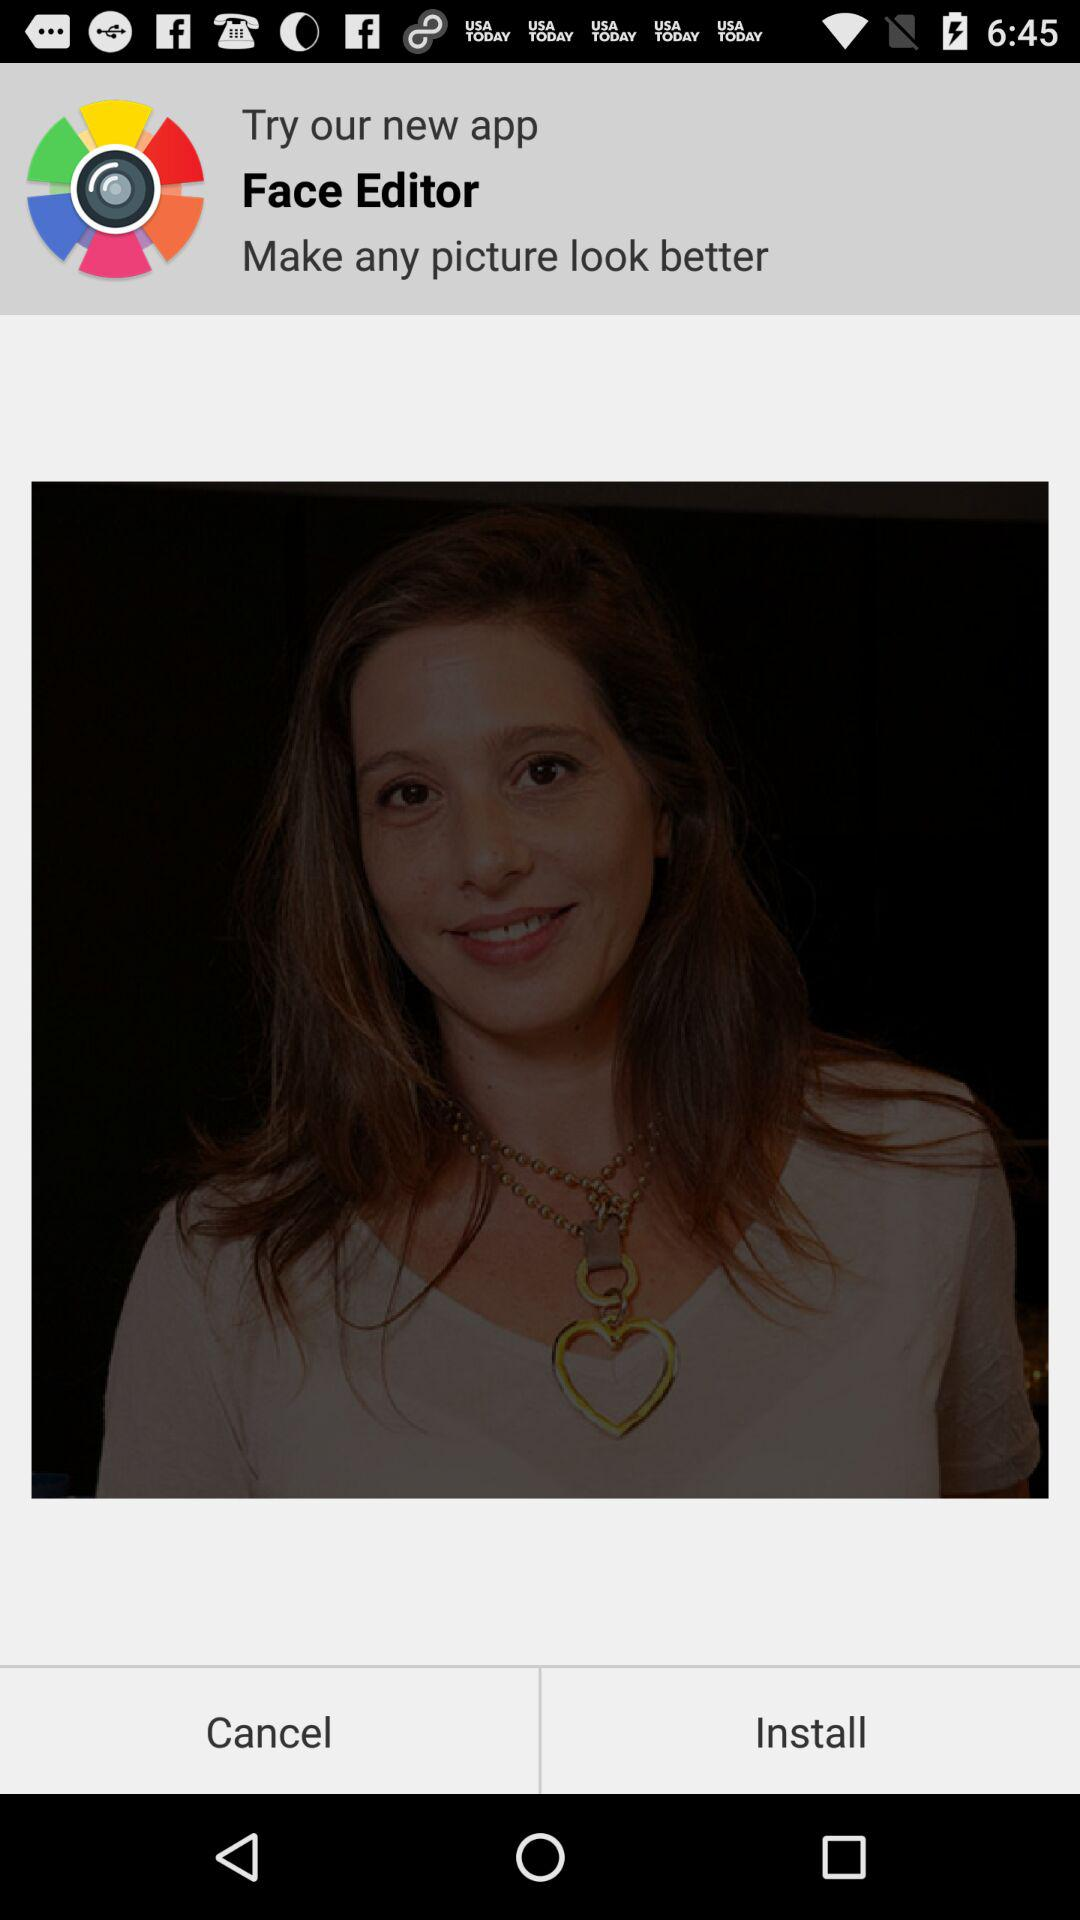What application is new? The new application is "Face Editor". 